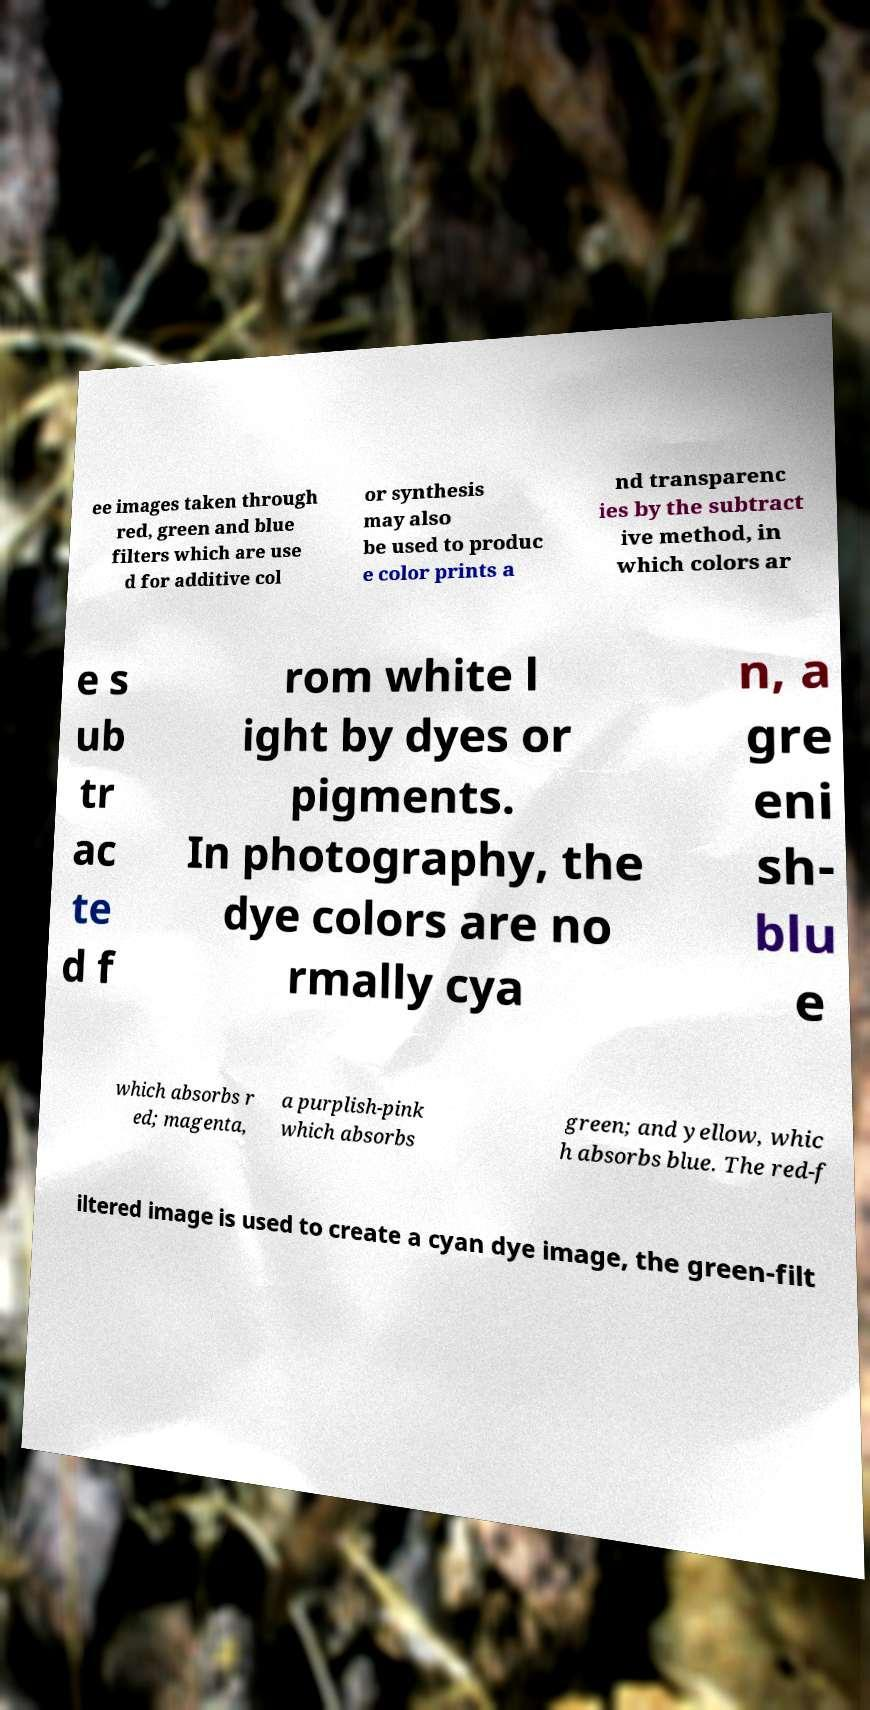Could you extract and type out the text from this image? ee images taken through red, green and blue filters which are use d for additive col or synthesis may also be used to produc e color prints a nd transparenc ies by the subtract ive method, in which colors ar e s ub tr ac te d f rom white l ight by dyes or pigments. In photography, the dye colors are no rmally cya n, a gre eni sh- blu e which absorbs r ed; magenta, a purplish-pink which absorbs green; and yellow, whic h absorbs blue. The red-f iltered image is used to create a cyan dye image, the green-filt 